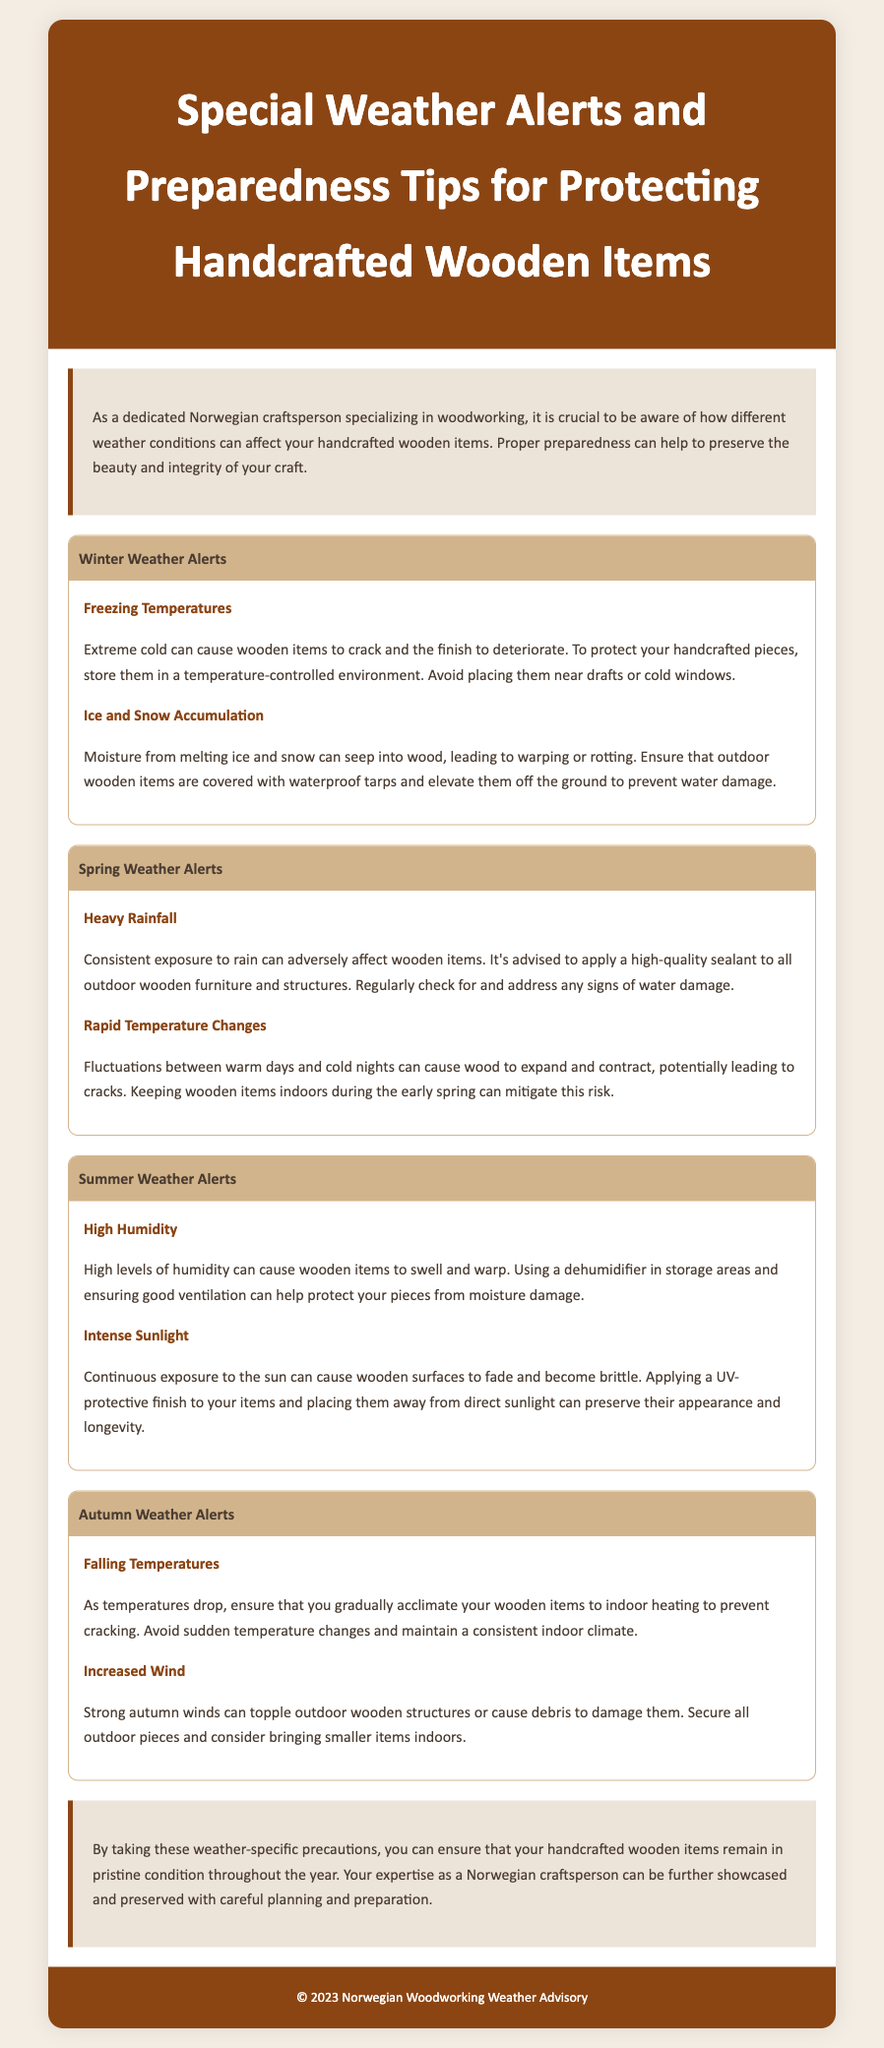What are the winter weather alerts? The document specifies two winter weather alerts: "Freezing Temperatures" and "Ice and Snow Accumulation."
Answer: Freezing Temperatures, Ice and Snow Accumulation What is one way to protect wooden items from icy conditions? The document mentions storing wooden items in a temperature-controlled environment to prevent cracking.
Answer: Temperature-controlled environment What should be done during heavy rainfall according to the spring weather alerts? The document advises applying a high-quality sealant to outdoor wooden furniture and structures during heavy rainfall.
Answer: Apply a high-quality sealant What can be a consequence of high humidity on wooden items? The document states that high humidity can cause wooden items to swell and warp.
Answer: Swell and warp What precaution is suggested for intense sunlight exposure? The document suggests applying a UV-protective finish and placing items away from direct sunlight.
Answer: UV-protective finish, away from direct sunlight What should be avoided to prevent cracking of wooden items as temperatures drop? The document advises avoiding sudden temperature changes as temperatures drop.
Answer: Sudden temperature changes How can outdoor wooden structures be protected from increased wind in autumn? The document recommends securing outdoor pieces and considering bringing smaller items indoors.
Answer: Secure outdoor pieces, bring smaller items indoors What environmental condition can lead to water damage in the spring? The document mentions consistent exposure to rain can lead to water damage.
Answer: Consistent exposure to rain 